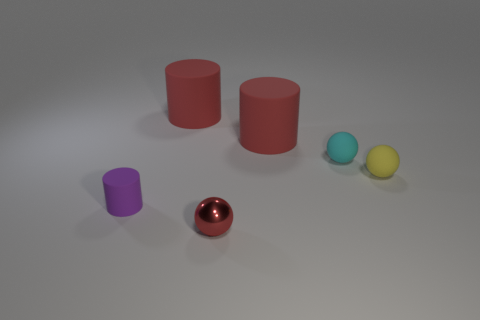Is there anything else that has the same material as the small red sphere?
Provide a short and direct response. No. Is the material of the red cylinder on the left side of the red shiny object the same as the tiny cyan sphere?
Your response must be concise. Yes. What number of other objects are there of the same size as the yellow rubber sphere?
Your answer should be very brief. 3. What number of big objects are yellow cylinders or yellow spheres?
Your answer should be compact. 0. Do the metal object and the small matte cylinder have the same color?
Keep it short and to the point. No. Is the number of tiny balls that are in front of the tiny purple thing greater than the number of tiny purple cylinders to the right of the yellow matte sphere?
Offer a terse response. Yes. There is a big object that is to the right of the red metal sphere; is its color the same as the small metal sphere?
Offer a very short reply. Yes. Is there any other thing that has the same color as the tiny rubber cylinder?
Ensure brevity in your answer.  No. Is the number of large rubber cylinders left of the tiny red sphere greater than the number of big green shiny objects?
Make the answer very short. Yes. Do the shiny ball and the purple rubber thing have the same size?
Offer a very short reply. Yes. 